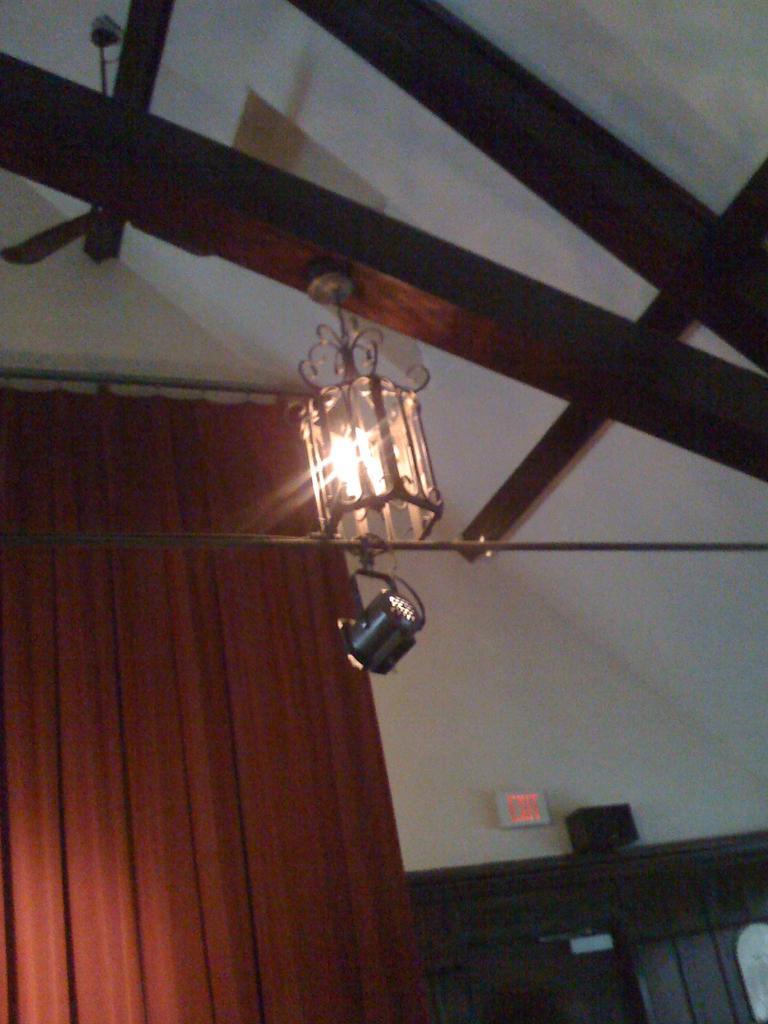Can you describe this image briefly? In this picture we can see lights, here we can see a wall, curtain, roof, wooden sticks and some objects. 